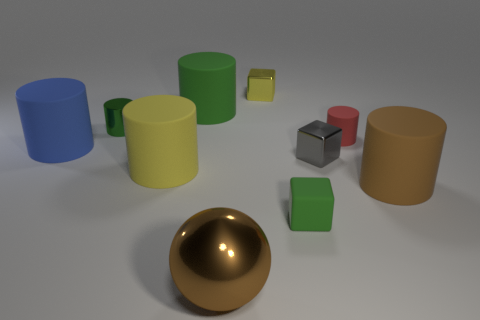There is a shiny thing right of the rubber cube; is it the same size as the big green cylinder?
Give a very brief answer. No. There is a matte cylinder that is both in front of the tiny gray object and on the left side of the small red rubber object; what is its size?
Offer a very short reply. Large. How many metal cylinders are the same size as the red matte cylinder?
Your answer should be compact. 1. There is a large object to the right of the brown metal sphere; what number of large green cylinders are in front of it?
Your response must be concise. 0. There is a matte cylinder that is on the right side of the red rubber object; is it the same color as the large shiny ball?
Provide a short and direct response. Yes. There is a big rubber cylinder that is on the right side of the big object that is behind the big blue thing; are there any small green objects that are in front of it?
Make the answer very short. Yes. What is the shape of the tiny object that is both behind the gray shiny object and right of the green rubber block?
Provide a short and direct response. Cylinder. Is there a small matte cylinder of the same color as the metal ball?
Provide a short and direct response. No. What color is the small object that is behind the large cylinder behind the small red matte object?
Your answer should be compact. Yellow. There is a yellow object in front of the metallic cube that is behind the green thing behind the tiny green cylinder; what size is it?
Ensure brevity in your answer.  Large. 